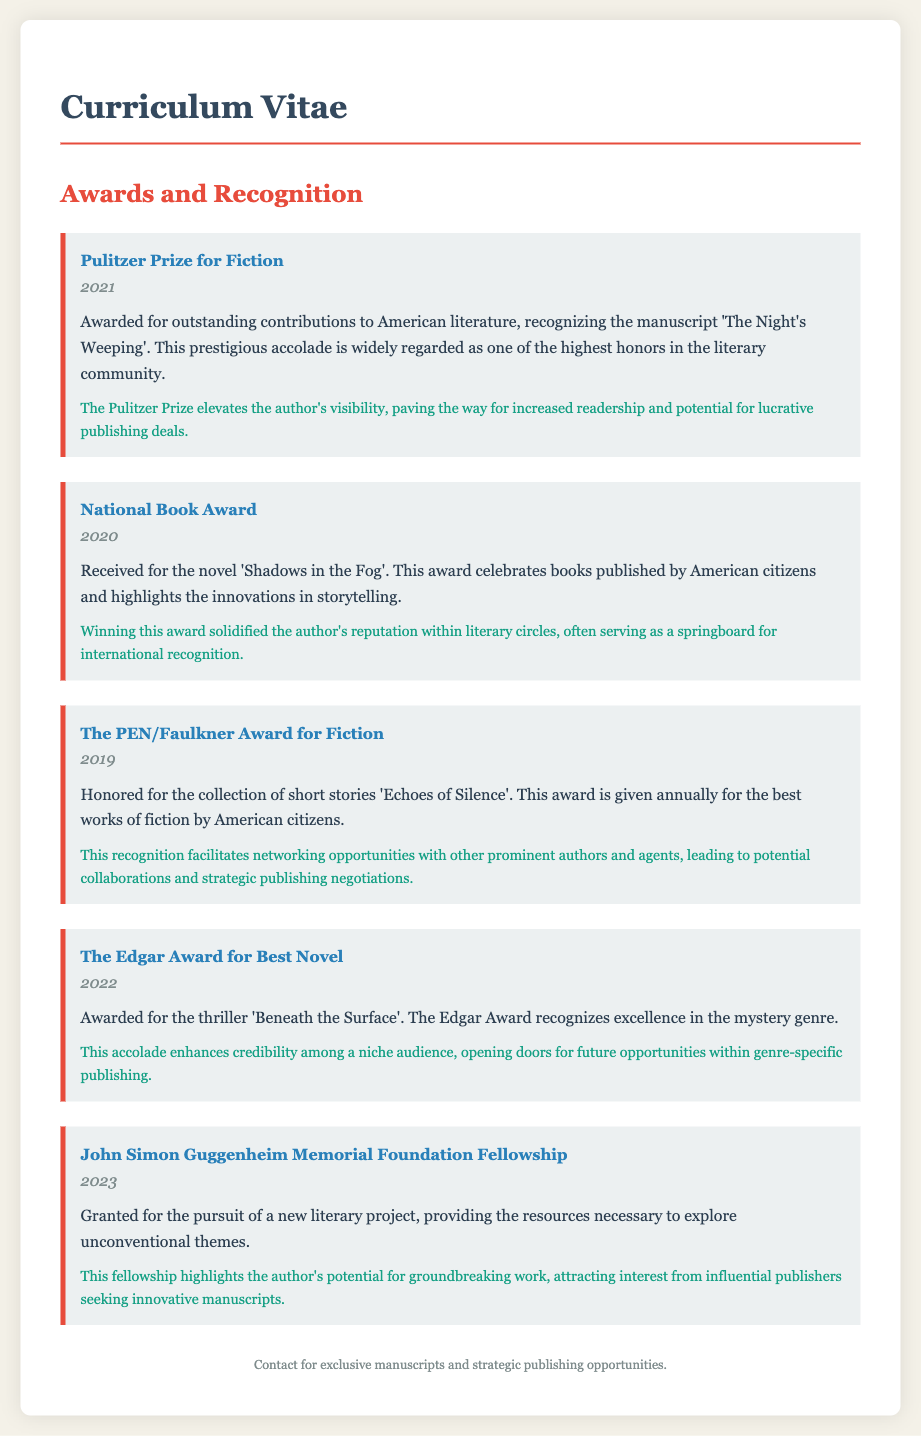What is the most recent award listed? The most recent award mentioned in the document is the John Simon Guggenheim Memorial Foundation Fellowship which was granted in 2023.
Answer: John Simon Guggenheim Memorial Foundation Fellowship Which award was received in 2021? The award received in 2021 is the Pulitzer Prize for Fiction, specifically for the manuscript 'The Night's Weeping'.
Answer: Pulitzer Prize for Fiction What is the significance of the National Book Award? The National Book Award solidified the author's reputation within literary circles and serves as a springboard for international recognition.
Answer: Solidified reputation Which award recognizes excellence in the mystery genre? The award that recognizes excellence in the mystery genre is The Edgar Award for Best Novel.
Answer: The Edgar Award for Best Novel What was the title of the work that won the PEN/Faulkner Award for Fiction? The title of the work that won the PEN/Faulkner Award for Fiction is 'Echoes of Silence'.
Answer: Echoes of Silence What was the publication year of 'Shadows in the Fog'? 'Shadows in the Fog' was published in 2020, the same year it won the National Book Award.
Answer: 2020 